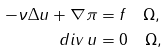<formula> <loc_0><loc_0><loc_500><loc_500>- \nu \Delta u + \nabla \pi & = f \quad \Omega , \\ d i v \, u & = 0 \quad \Omega ,</formula> 